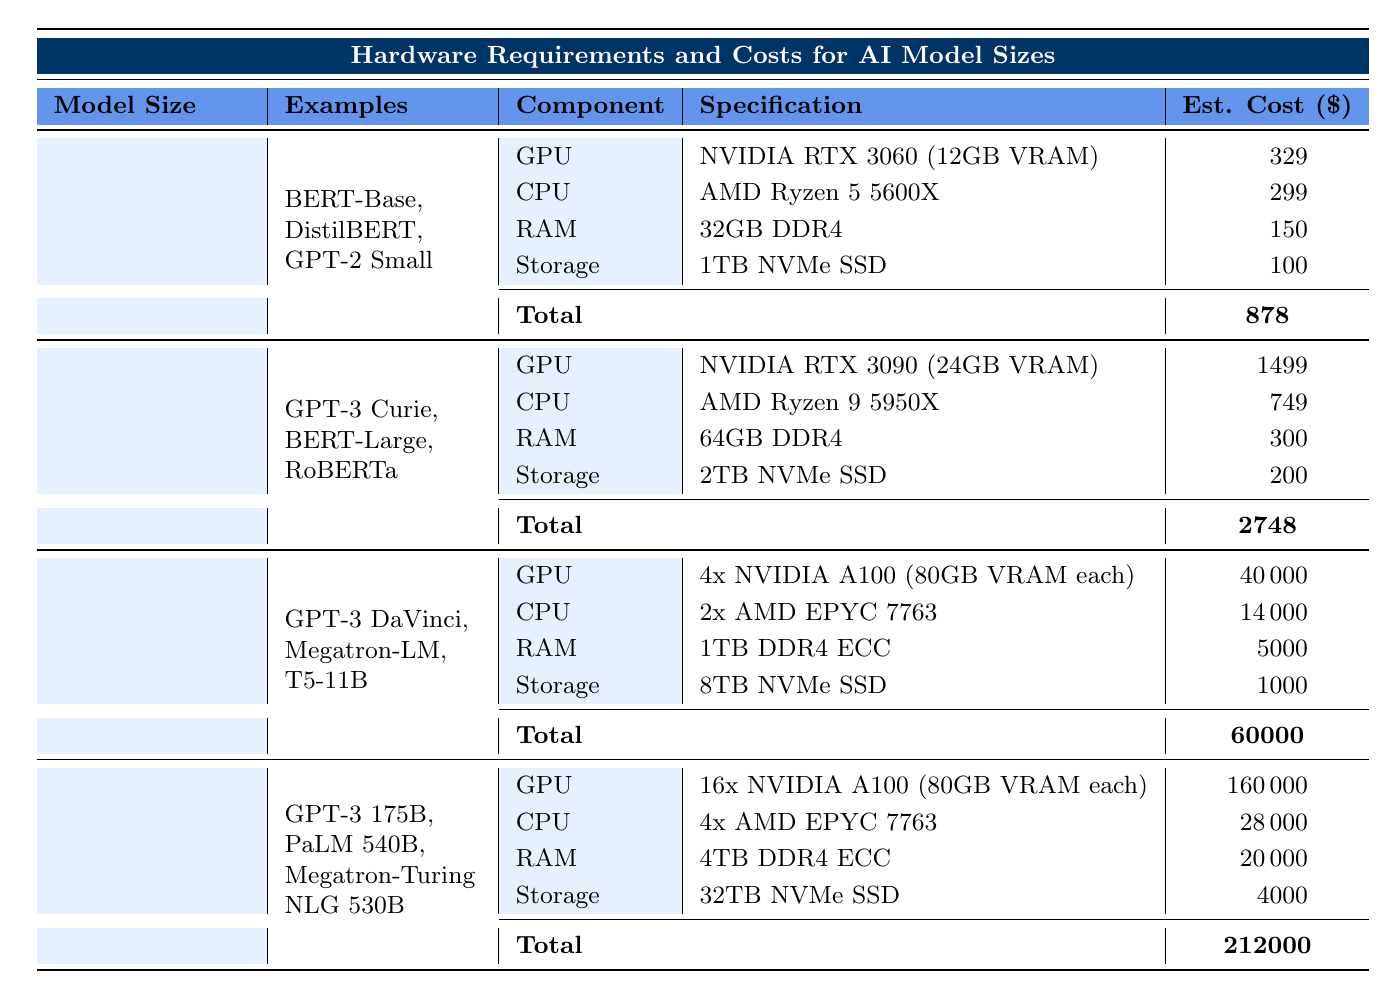What is the total estimated cost for a Medium AI model? The total estimated cost for the Medium AI model size is clearly listed in the table, which shows a value of $2,748.
Answer: $2,748 Which component has the highest cost in the Large AI model category? In the Large AI model category, the GPU component, listed as 4x NVIDIA A100, has the highest cost of $40,000 compared to the other components (CPU, RAM, Storage).
Answer: GPU Are there more components listed for the Very Large or Large AI model size? Both the Very Large and Large AI model sizes have the same number of components listed, which is four (GPU, CPU, RAM, Storage). Therefore, the answer is no; they are equal.
Answer: No What is the total cost difference between a Small and a Very Large AI model? The total estimated cost for the Small AI model is $878 while for the Very Large model, it is $212,000. The cost difference is calculated as $212,000 - $878 = $211,122.
Answer: $211,122 True or False: The GPU requirement for the Medium model is more expensive than that of the Small model. The GPU requirement for the Medium model is $1,499 while for the Small model it is $329. Since $1,499 is greater than $329, the statement is true.
Answer: True What is the total estimated cost for all components in the Very Large AI model? The total estimated cost for all components in the Very Large model is listed in the table as $212,000, which is already provided and represents the sum of all individual component costs.
Answer: $212,000 If I wanted to build a Medium AI model, how much would I spend on RAM? For the Medium AI model, the RAM requirement is stated as 64GB DDR4, which costs $300 according to the table.
Answer: $300 What is the ratio of the total estimated cost of the Large AI model to that of the Small AI model? The total costs are $60,000 for the Large model and $878 for the Small model. The ratio is calculated as $60,000 / $878, which simplifies to approximately 68.25.
Answer: 68.25 Which model size has a total estimated cost closest to $1,000? By comparing the total estimated costs for all model sizes listed, the Small model costs $878, which is closest to $1,000 compared to the Medium and Large models.
Answer: Small What is the average estimated cost of RAM across all AI model sizes? The cost of RAM for each model size is $150 (Small), $300 (Medium), $5,000 (Large), and $20,000 (Very Large). The average is calculated as ($150 + $300 + $5,000 + $20,000) / 4 = $6,612.50.
Answer: $6,612.50 